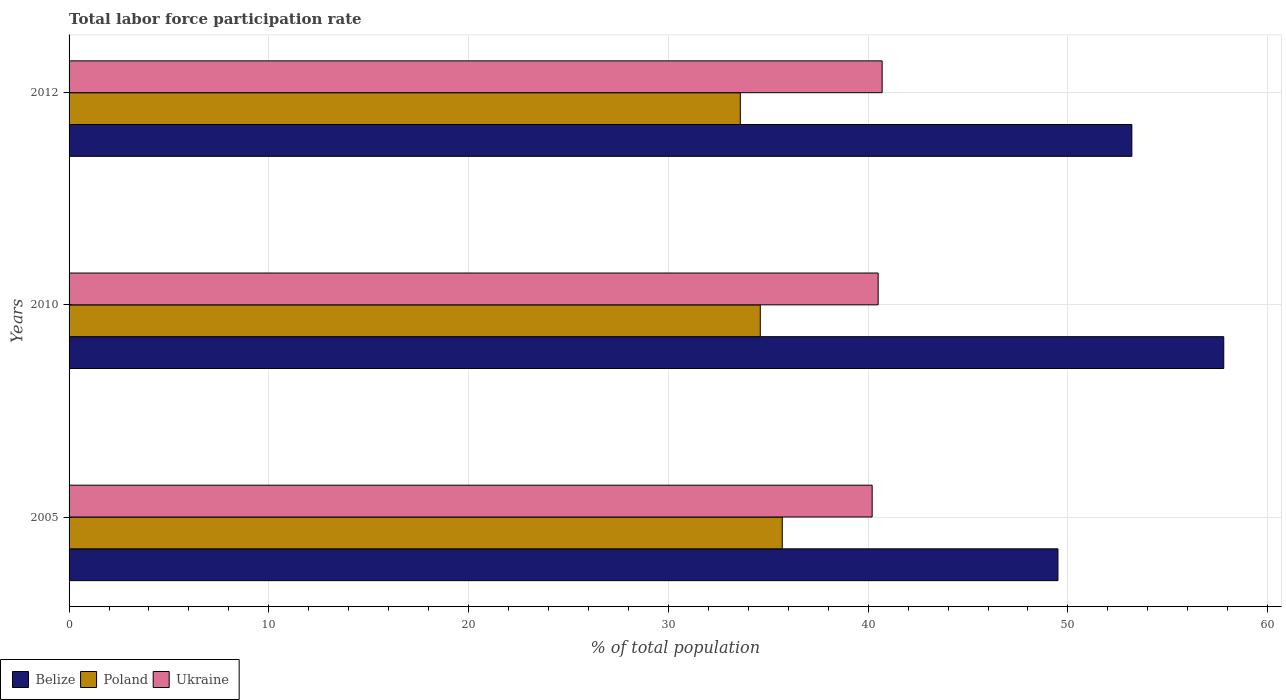Are the number of bars per tick equal to the number of legend labels?
Ensure brevity in your answer.  Yes. What is the label of the 3rd group of bars from the top?
Ensure brevity in your answer.  2005. In how many cases, is the number of bars for a given year not equal to the number of legend labels?
Offer a very short reply. 0. What is the total labor force participation rate in Ukraine in 2012?
Give a very brief answer. 40.7. Across all years, what is the maximum total labor force participation rate in Belize?
Your response must be concise. 57.8. Across all years, what is the minimum total labor force participation rate in Ukraine?
Offer a very short reply. 40.2. In which year was the total labor force participation rate in Belize maximum?
Give a very brief answer. 2010. What is the total total labor force participation rate in Belize in the graph?
Offer a very short reply. 160.5. What is the difference between the total labor force participation rate in Belize in 2010 and that in 2012?
Provide a succinct answer. 4.6. What is the difference between the total labor force participation rate in Poland in 2005 and the total labor force participation rate in Belize in 2012?
Provide a succinct answer. -17.5. What is the average total labor force participation rate in Ukraine per year?
Provide a short and direct response. 40.47. In the year 2012, what is the difference between the total labor force participation rate in Ukraine and total labor force participation rate in Poland?
Provide a succinct answer. 7.1. In how many years, is the total labor force participation rate in Ukraine greater than 54 %?
Ensure brevity in your answer.  0. What is the ratio of the total labor force participation rate in Poland in 2005 to that in 2010?
Provide a succinct answer. 1.03. Is the difference between the total labor force participation rate in Ukraine in 2005 and 2010 greater than the difference between the total labor force participation rate in Poland in 2005 and 2010?
Your response must be concise. No. What is the difference between the highest and the second highest total labor force participation rate in Belize?
Offer a terse response. 4.6. What is the difference between the highest and the lowest total labor force participation rate in Poland?
Offer a very short reply. 2.1. In how many years, is the total labor force participation rate in Belize greater than the average total labor force participation rate in Belize taken over all years?
Give a very brief answer. 1. What does the 3rd bar from the top in 2005 represents?
Provide a succinct answer. Belize. What does the 1st bar from the bottom in 2012 represents?
Give a very brief answer. Belize. Is it the case that in every year, the sum of the total labor force participation rate in Poland and total labor force participation rate in Ukraine is greater than the total labor force participation rate in Belize?
Provide a short and direct response. Yes. How many bars are there?
Provide a short and direct response. 9. What is the difference between two consecutive major ticks on the X-axis?
Your answer should be compact. 10. Are the values on the major ticks of X-axis written in scientific E-notation?
Offer a terse response. No. Does the graph contain any zero values?
Provide a succinct answer. No. How many legend labels are there?
Make the answer very short. 3. What is the title of the graph?
Keep it short and to the point. Total labor force participation rate. What is the label or title of the X-axis?
Make the answer very short. % of total population. What is the label or title of the Y-axis?
Your answer should be very brief. Years. What is the % of total population in Belize in 2005?
Your response must be concise. 49.5. What is the % of total population in Poland in 2005?
Offer a terse response. 35.7. What is the % of total population of Ukraine in 2005?
Ensure brevity in your answer.  40.2. What is the % of total population of Belize in 2010?
Offer a very short reply. 57.8. What is the % of total population of Poland in 2010?
Provide a succinct answer. 34.6. What is the % of total population in Ukraine in 2010?
Keep it short and to the point. 40.5. What is the % of total population in Belize in 2012?
Provide a short and direct response. 53.2. What is the % of total population in Poland in 2012?
Your response must be concise. 33.6. What is the % of total population in Ukraine in 2012?
Provide a short and direct response. 40.7. Across all years, what is the maximum % of total population of Belize?
Provide a succinct answer. 57.8. Across all years, what is the maximum % of total population in Poland?
Your response must be concise. 35.7. Across all years, what is the maximum % of total population in Ukraine?
Offer a very short reply. 40.7. Across all years, what is the minimum % of total population of Belize?
Your answer should be compact. 49.5. Across all years, what is the minimum % of total population of Poland?
Offer a terse response. 33.6. Across all years, what is the minimum % of total population in Ukraine?
Ensure brevity in your answer.  40.2. What is the total % of total population in Belize in the graph?
Offer a very short reply. 160.5. What is the total % of total population in Poland in the graph?
Provide a short and direct response. 103.9. What is the total % of total population in Ukraine in the graph?
Make the answer very short. 121.4. What is the difference between the % of total population of Poland in 2005 and that in 2010?
Ensure brevity in your answer.  1.1. What is the difference between the % of total population of Ukraine in 2005 and that in 2010?
Offer a very short reply. -0.3. What is the difference between the % of total population of Belize in 2005 and that in 2012?
Offer a very short reply. -3.7. What is the difference between the % of total population in Poland in 2005 and that in 2012?
Ensure brevity in your answer.  2.1. What is the difference between the % of total population in Poland in 2010 and that in 2012?
Provide a short and direct response. 1. What is the difference between the % of total population of Belize in 2005 and the % of total population of Ukraine in 2010?
Give a very brief answer. 9. What is the difference between the % of total population in Poland in 2005 and the % of total population in Ukraine in 2010?
Offer a very short reply. -4.8. What is the difference between the % of total population in Belize in 2005 and the % of total population in Poland in 2012?
Offer a very short reply. 15.9. What is the difference between the % of total population of Belize in 2010 and the % of total population of Poland in 2012?
Your answer should be very brief. 24.2. What is the average % of total population of Belize per year?
Offer a terse response. 53.5. What is the average % of total population in Poland per year?
Keep it short and to the point. 34.63. What is the average % of total population of Ukraine per year?
Your answer should be compact. 40.47. In the year 2005, what is the difference between the % of total population of Belize and % of total population of Poland?
Ensure brevity in your answer.  13.8. In the year 2010, what is the difference between the % of total population in Belize and % of total population in Poland?
Make the answer very short. 23.2. In the year 2010, what is the difference between the % of total population of Poland and % of total population of Ukraine?
Offer a very short reply. -5.9. In the year 2012, what is the difference between the % of total population of Belize and % of total population of Poland?
Provide a succinct answer. 19.6. In the year 2012, what is the difference between the % of total population of Poland and % of total population of Ukraine?
Your answer should be very brief. -7.1. What is the ratio of the % of total population of Belize in 2005 to that in 2010?
Offer a terse response. 0.86. What is the ratio of the % of total population of Poland in 2005 to that in 2010?
Your response must be concise. 1.03. What is the ratio of the % of total population in Ukraine in 2005 to that in 2010?
Make the answer very short. 0.99. What is the ratio of the % of total population in Belize in 2005 to that in 2012?
Provide a succinct answer. 0.93. What is the ratio of the % of total population of Belize in 2010 to that in 2012?
Provide a short and direct response. 1.09. What is the ratio of the % of total population in Poland in 2010 to that in 2012?
Give a very brief answer. 1.03. What is the ratio of the % of total population in Ukraine in 2010 to that in 2012?
Ensure brevity in your answer.  1. What is the difference between the highest and the second highest % of total population of Belize?
Ensure brevity in your answer.  4.6. What is the difference between the highest and the second highest % of total population of Poland?
Make the answer very short. 1.1. What is the difference between the highest and the lowest % of total population in Poland?
Offer a very short reply. 2.1. What is the difference between the highest and the lowest % of total population of Ukraine?
Provide a short and direct response. 0.5. 